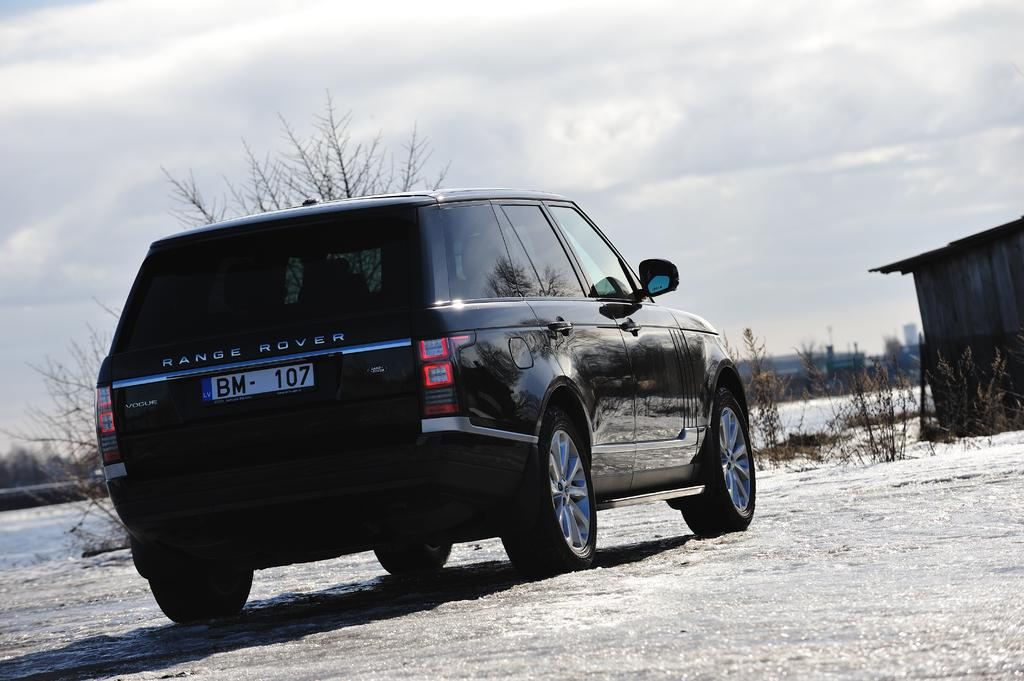What is the main object on the ground in the image? There is a car on the ground in the image. What type of vegetation can be seen in the image? There are trees, bushes, and plants in the image. What type of structure is present in the image? There is a shed in the image. What is visible on the ground in the image? There are objects and grass on the ground in the image. What is visible at the top of the image? The sky is visible at the top of the image. How does the snake compare to the car in the image? There is no snake present in the image, so it cannot be compared to the car. 